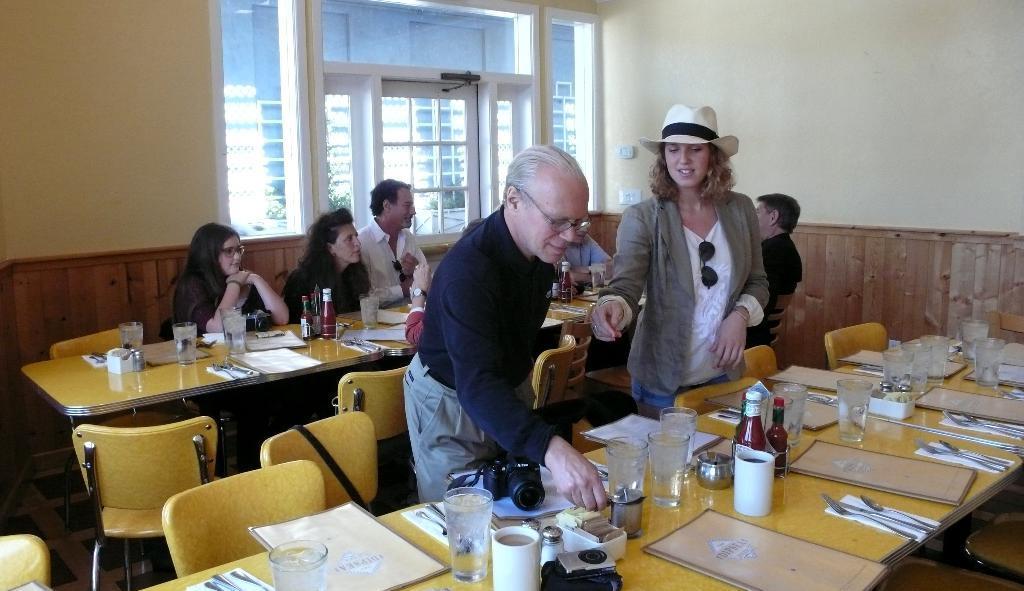In one or two sentences, can you explain what this image depicts? In the picture there is a room in that room there is a dining hall there are two persons standing and some people are sitting on the chair with the table in front of them on the table there are many items such as glass,spoons,tissues,cup,bottles camera,bowls near to the wall there is a window. 